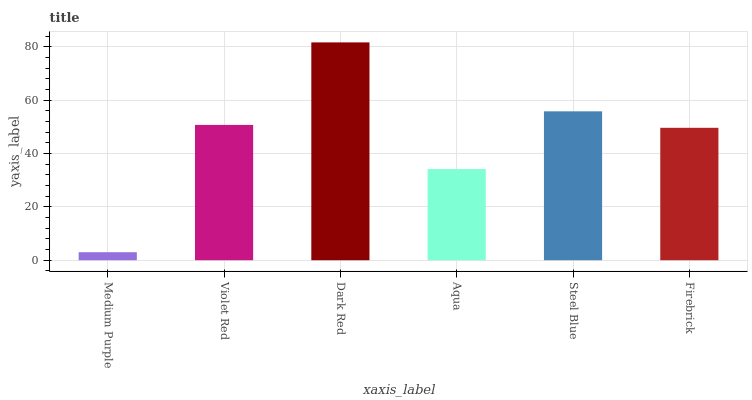Is Medium Purple the minimum?
Answer yes or no. Yes. Is Dark Red the maximum?
Answer yes or no. Yes. Is Violet Red the minimum?
Answer yes or no. No. Is Violet Red the maximum?
Answer yes or no. No. Is Violet Red greater than Medium Purple?
Answer yes or no. Yes. Is Medium Purple less than Violet Red?
Answer yes or no. Yes. Is Medium Purple greater than Violet Red?
Answer yes or no. No. Is Violet Red less than Medium Purple?
Answer yes or no. No. Is Violet Red the high median?
Answer yes or no. Yes. Is Firebrick the low median?
Answer yes or no. Yes. Is Firebrick the high median?
Answer yes or no. No. Is Steel Blue the low median?
Answer yes or no. No. 